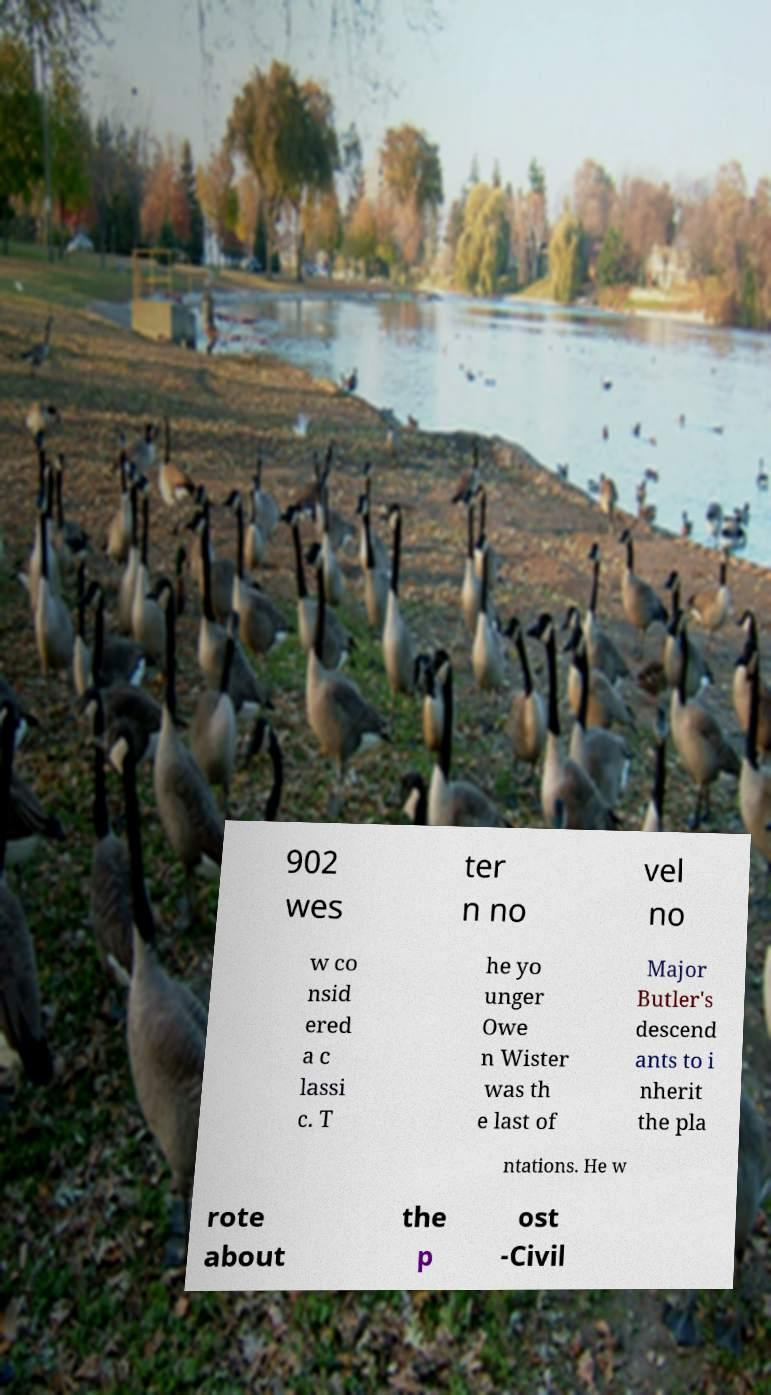Could you assist in decoding the text presented in this image and type it out clearly? 902 wes ter n no vel no w co nsid ered a c lassi c. T he yo unger Owe n Wister was th e last of Major Butler's descend ants to i nherit the pla ntations. He w rote about the p ost -Civil 